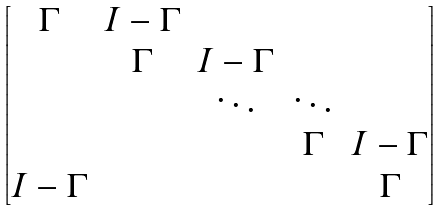Convert formula to latex. <formula><loc_0><loc_0><loc_500><loc_500>\begin{bmatrix} \Gamma & I - \Gamma & & \\ & \Gamma & I - \Gamma & \\ & & \ddots & \ddots \\ & & & \Gamma & I - \Gamma \\ I - \Gamma & & & & \Gamma \end{bmatrix}</formula> 